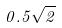Convert formula to latex. <formula><loc_0><loc_0><loc_500><loc_500>0 . 5 \sqrt { 2 }</formula> 